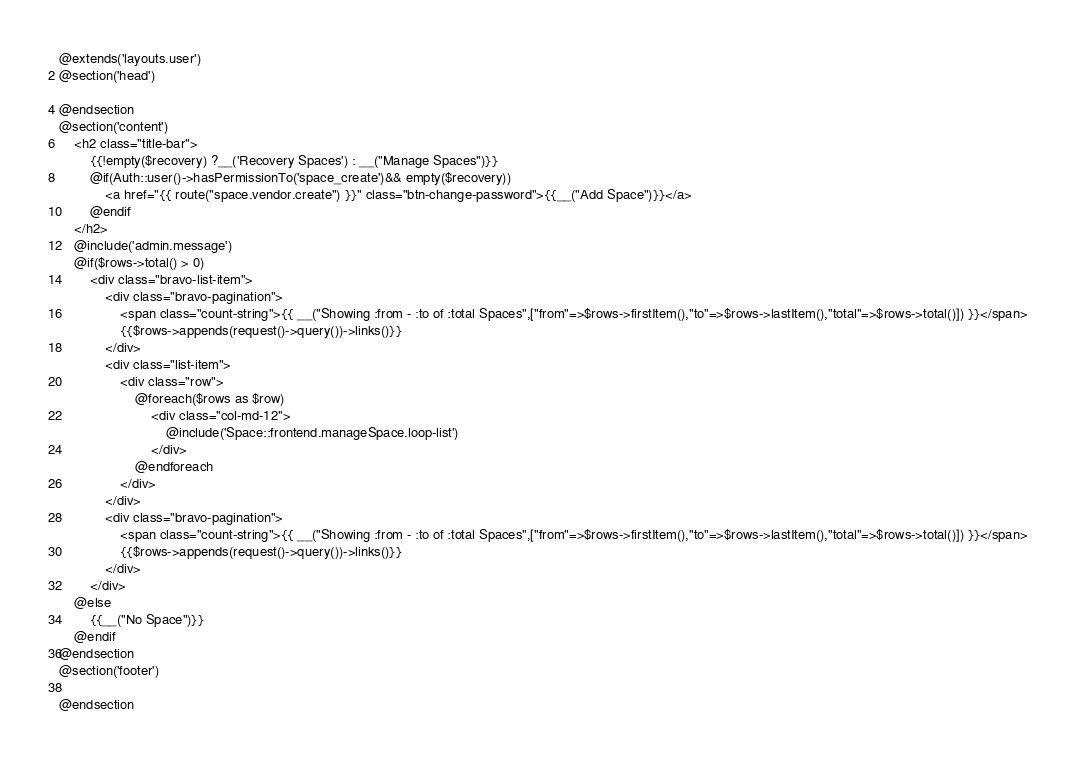<code> <loc_0><loc_0><loc_500><loc_500><_PHP_>@extends('layouts.user')
@section('head')

@endsection
@section('content')
    <h2 class="title-bar">
        {{!empty($recovery) ?__('Recovery Spaces') : __("Manage Spaces")}}
        @if(Auth::user()->hasPermissionTo('space_create')&& empty($recovery))
            <a href="{{ route("space.vendor.create") }}" class="btn-change-password">{{__("Add Space")}}</a>
        @endif
    </h2>
    @include('admin.message')
    @if($rows->total() > 0)
        <div class="bravo-list-item">
            <div class="bravo-pagination">
                <span class="count-string">{{ __("Showing :from - :to of :total Spaces",["from"=>$rows->firstItem(),"to"=>$rows->lastItem(),"total"=>$rows->total()]) }}</span>
                {{$rows->appends(request()->query())->links()}}
            </div>
            <div class="list-item">
                <div class="row">
                    @foreach($rows as $row)
                        <div class="col-md-12">
                            @include('Space::frontend.manageSpace.loop-list')
                        </div>
                    @endforeach
                </div>
            </div>
            <div class="bravo-pagination">
                <span class="count-string">{{ __("Showing :from - :to of :total Spaces",["from"=>$rows->firstItem(),"to"=>$rows->lastItem(),"total"=>$rows->total()]) }}</span>
                {{$rows->appends(request()->query())->links()}}
            </div>
        </div>
    @else
        {{__("No Space")}}
    @endif
@endsection
@section('footer')

@endsection
</code> 